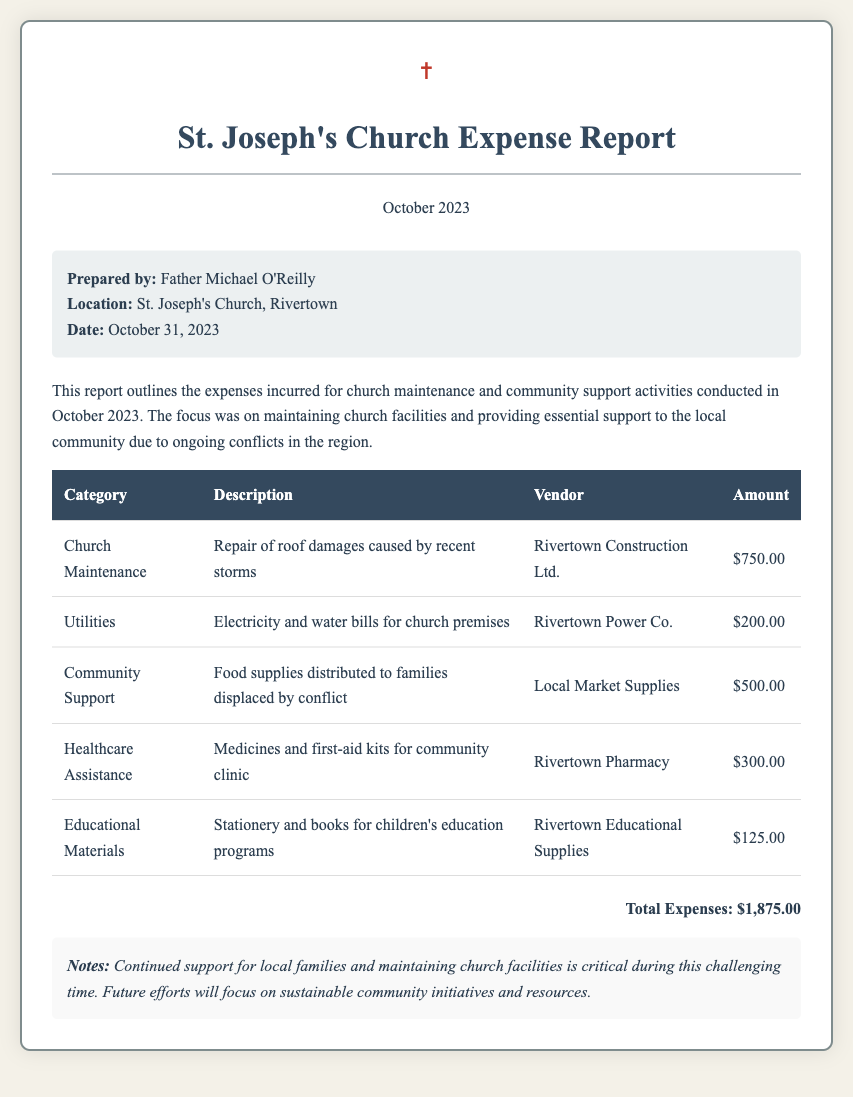What is the title of the document? The title is presented at the top of the document to indicate its purpose.
Answer: Church Expense Report - October 2023 Who prepared the report? The name of the individual responsible for the report is mentioned in the summary section.
Answer: Father Michael O'Reilly What is the total expense amount? The total expense is calculated by summing all individual expenses listed in the table.
Answer: $1,875.00 How much was spent on food supplies? The amount spent on a specific category is indicated in the expense details.
Answer: $500.00 Which vendor was used for the roof repair? The vendor responsible for a specific service is mentioned in the corresponding entry.
Answer: Rivertown Construction Ltd What type of assistance did the church provide to the community? The document specifies the nature of support provided by the church, which is detailed in the report.
Answer: Food supplies What category had the highest expense? Identifying the category with the highest financial allocation requires comparing all listed expenses.
Answer: Church Maintenance What was one of the notes mentioned in the report? Important remarks or observations related to the document are included in the notes section.
Answer: Continued support for local families and maintaining church facilities is critical during this challenging time 